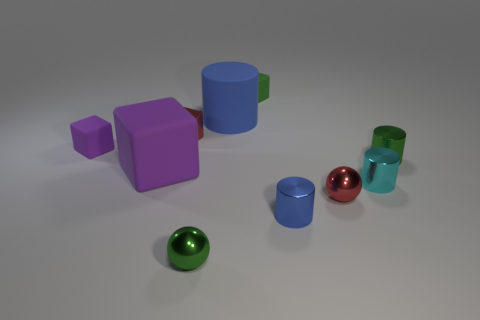What is the size of the other metallic cylinder that is the same color as the big cylinder?
Your answer should be very brief. Small. Is there a large cyan object made of the same material as the tiny green ball?
Ensure brevity in your answer.  No. Is the material of the big object on the left side of the big blue matte cylinder the same as the tiny purple block left of the big blue rubber object?
Offer a very short reply. Yes. What number of large cyan shiny cubes are there?
Keep it short and to the point. 0. The tiny object in front of the blue metal thing has what shape?
Offer a terse response. Sphere. What number of other things are there of the same size as the green shiny ball?
Give a very brief answer. 7. Do the tiny rubber thing that is behind the shiny block and the blue thing in front of the large blue cylinder have the same shape?
Your response must be concise. No. There is a green metal cylinder; how many matte objects are behind it?
Ensure brevity in your answer.  3. The large thing on the left side of the small red block is what color?
Ensure brevity in your answer.  Purple. What is the color of the tiny metal thing that is the same shape as the small purple rubber object?
Provide a short and direct response. Red. 